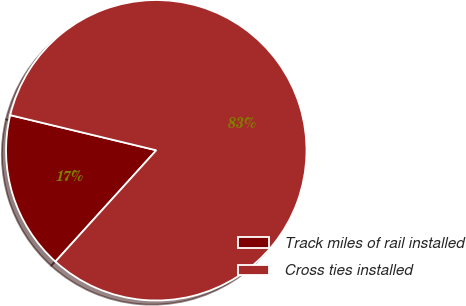Convert chart to OTSL. <chart><loc_0><loc_0><loc_500><loc_500><pie_chart><fcel>Track miles of rail installed<fcel>Cross ties installed<nl><fcel>17.04%<fcel>82.96%<nl></chart> 